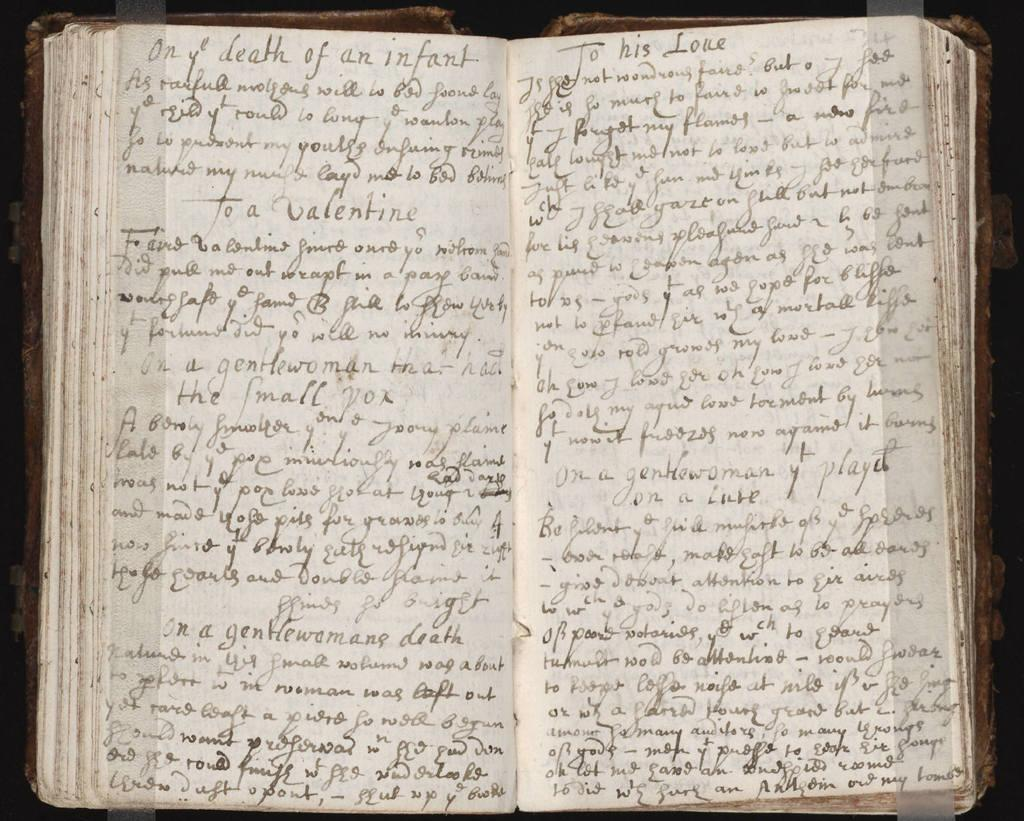<image>
Share a concise interpretation of the image provided. Open book with the words " To His Love" near the top. 